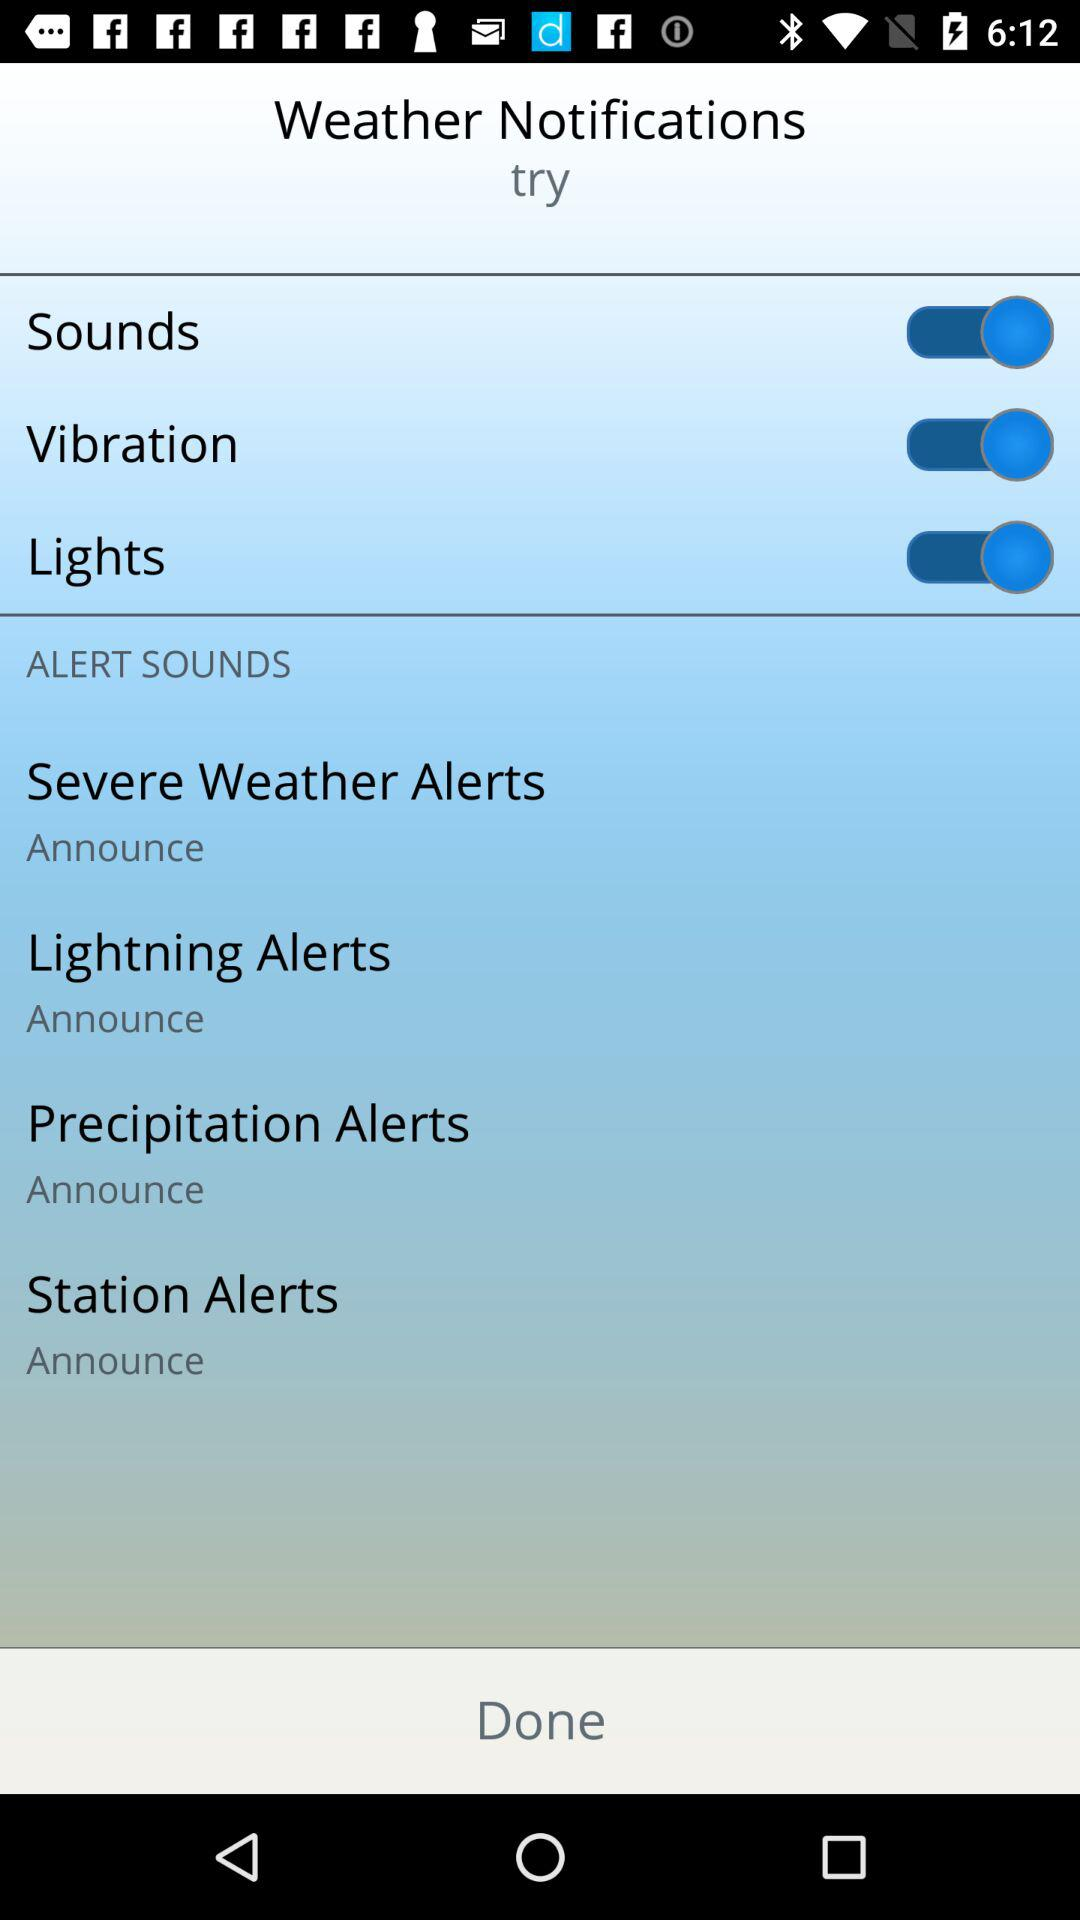What is the status of "Lights"? The status of "Lights" is "on". 